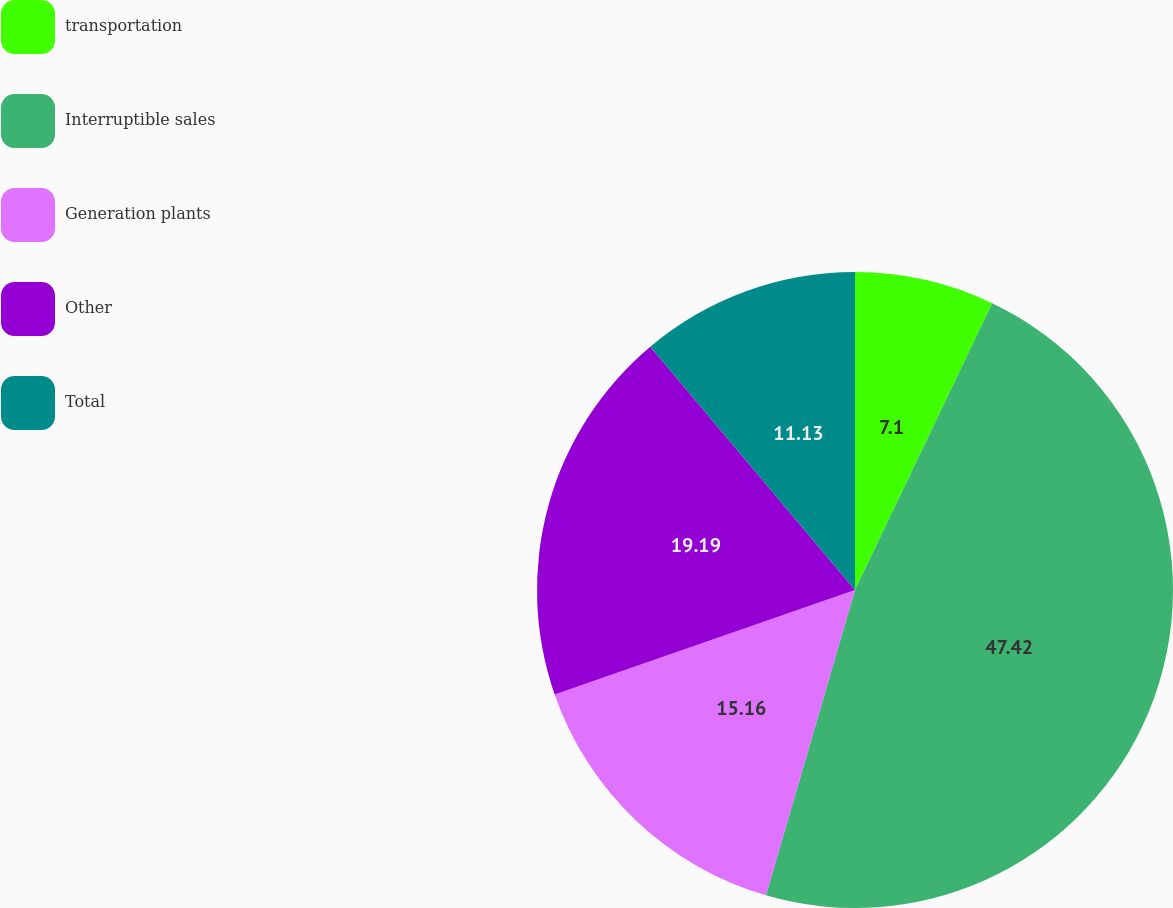Convert chart. <chart><loc_0><loc_0><loc_500><loc_500><pie_chart><fcel>transportation<fcel>Interruptible sales<fcel>Generation plants<fcel>Other<fcel>Total<nl><fcel>7.1%<fcel>47.41%<fcel>15.16%<fcel>19.19%<fcel>11.13%<nl></chart> 